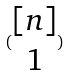Convert formula to latex. <formula><loc_0><loc_0><loc_500><loc_500>( \begin{matrix} [ n ] \\ 1 \end{matrix} )</formula> 